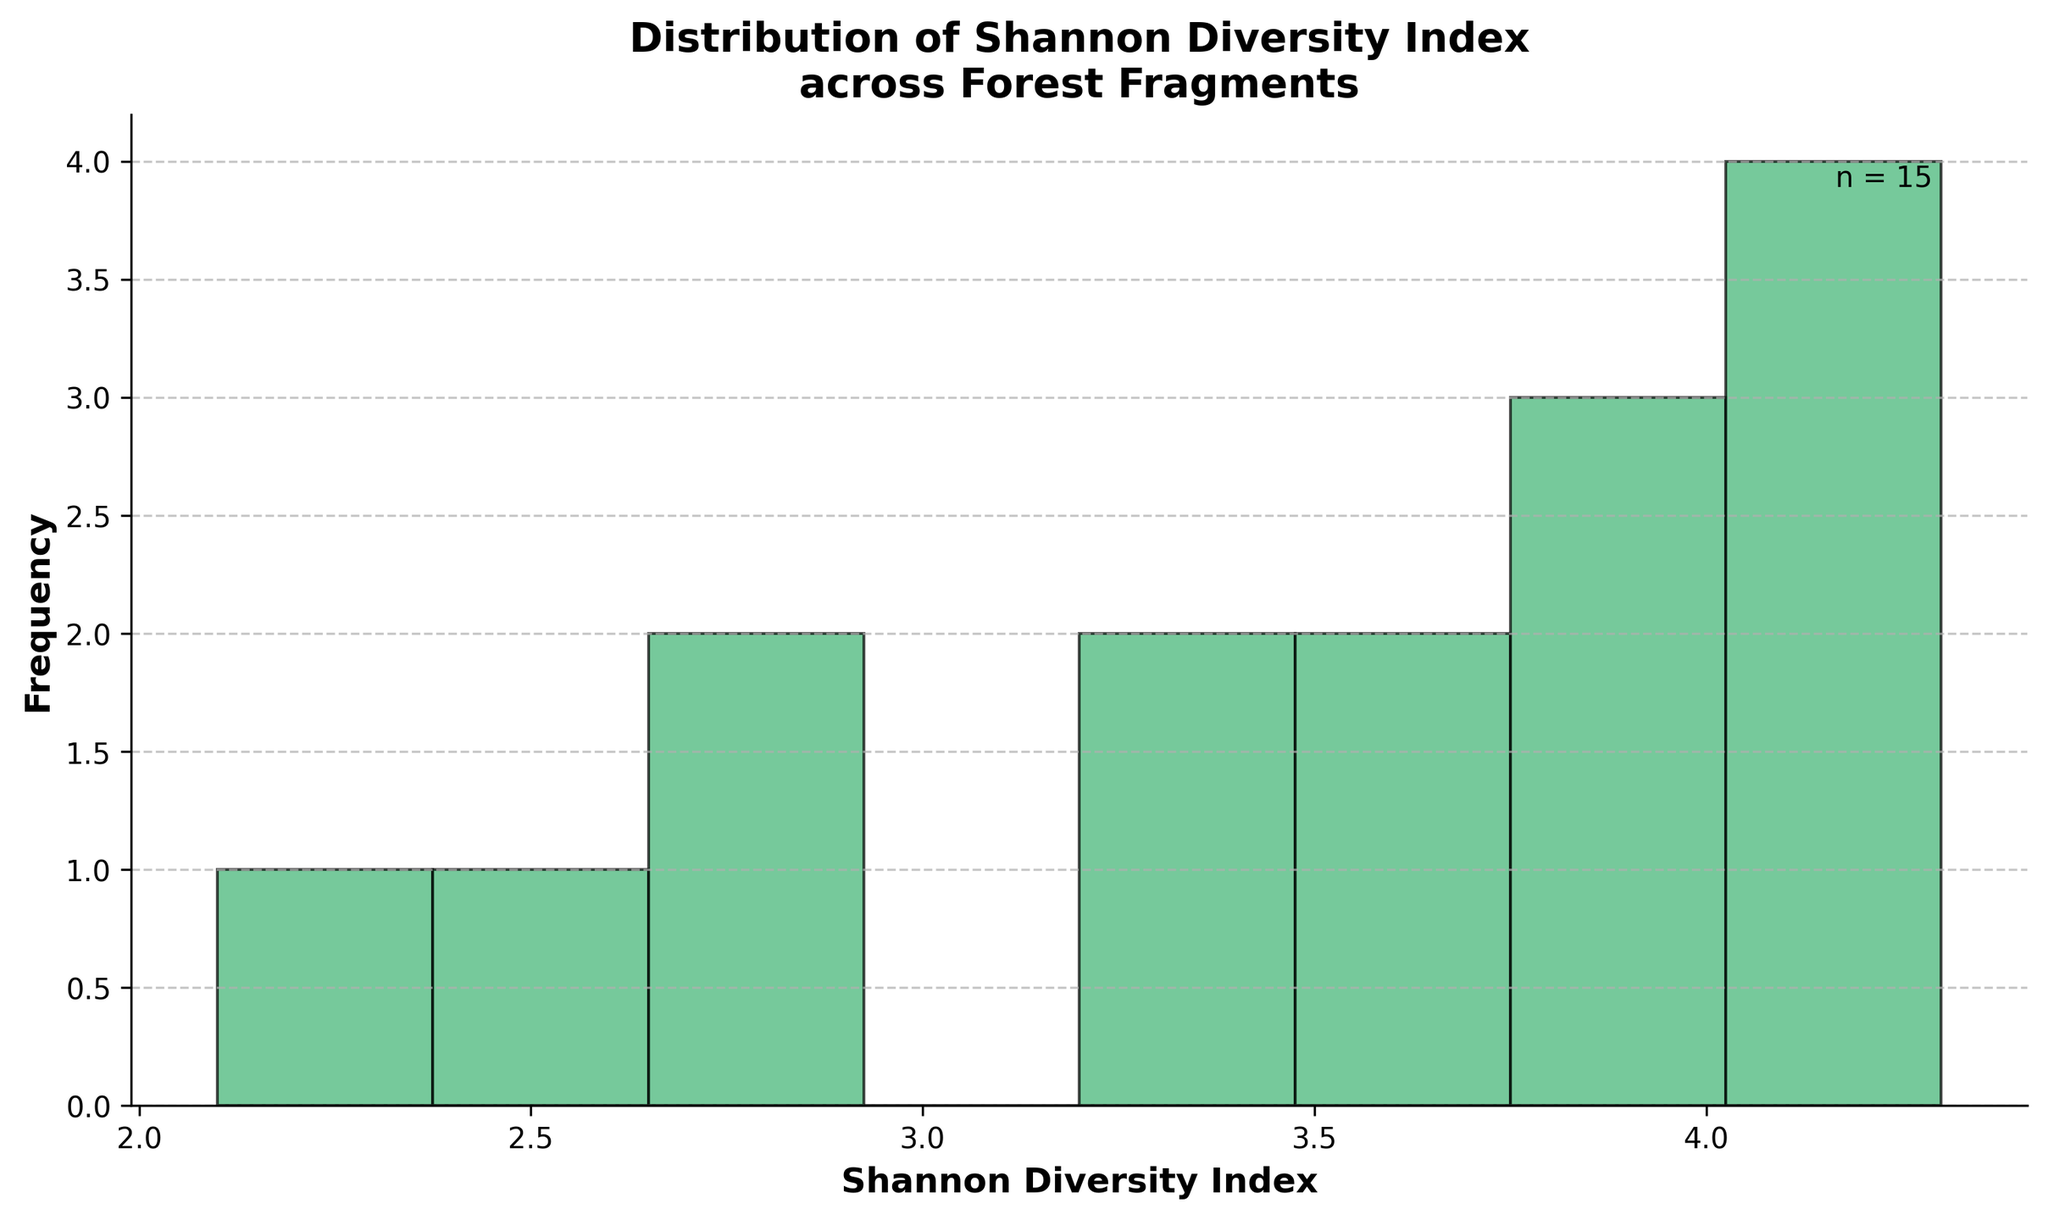What is the title of the figure? The title is usually displayed at the top of the figure. Here, it is "Distribution of Shannon Diversity Index across Forest Fragments."
Answer: Distribution of Shannon Diversity Index across Forest Fragments How many bins are used in the histogram? The number of bins can be identified by counting the distinct bars in the histogram. The figure uses 8 bins.
Answer: 8 What does the x-axis represent? The x-axis is labeled, indicating the variable being measured, which is the "Shannon Diversity Index."
Answer: Shannon Diversity Index What does the y-axis represent? The y-axis label indicates what is being counted in the bins, which is "Frequency."
Answer: Frequency How many data points are included in this histogram? The text on the figure shows "n = 15," which indicates that there are 15 data points used to create the histogram.
Answer: 15 What's the range of the Shannon Diversity Index values depicted in the histogram? The range can be determined by noting the minimum and maximum values on the x-axis, spanning from approximately 2.1 to 4.3.
Answer: 2.1 to 4.3 How many fragments have a Shannon Diversity Index between 3.0 and 3.5? By observing the bars in the relevant bin range, you can count how many fragments fall within this index range. The bar between 3.0 and 3.5 shows 2 fragments.
Answer: 2 Which bin has the highest frequency, and what is its range? By examining the height of the bars, you can identify the tallest bin, which indicates the highest frequency. The bin with the highest frequency ranges from 4.1 to 4.3.
Answer: 4.1 to 4.3 What is the median value of the Shannon Diversity Index based on the histogram? We count the middle value in the sorted list of indices. With 15 values, the median is the 8th value when arranged in ascending order. The mirrored part of 4-4.2 bin shows its maximum frequency from 4.2.
Answer: 4.0 Are there more fragments with Shannon Diversity Index above or below 3.5? Counting the number of fragments in bins above and below the 3.5 mark, more fragments lie in bins below (3 bins:8-2=6)  than above (4-6=2).
Answer: Below 